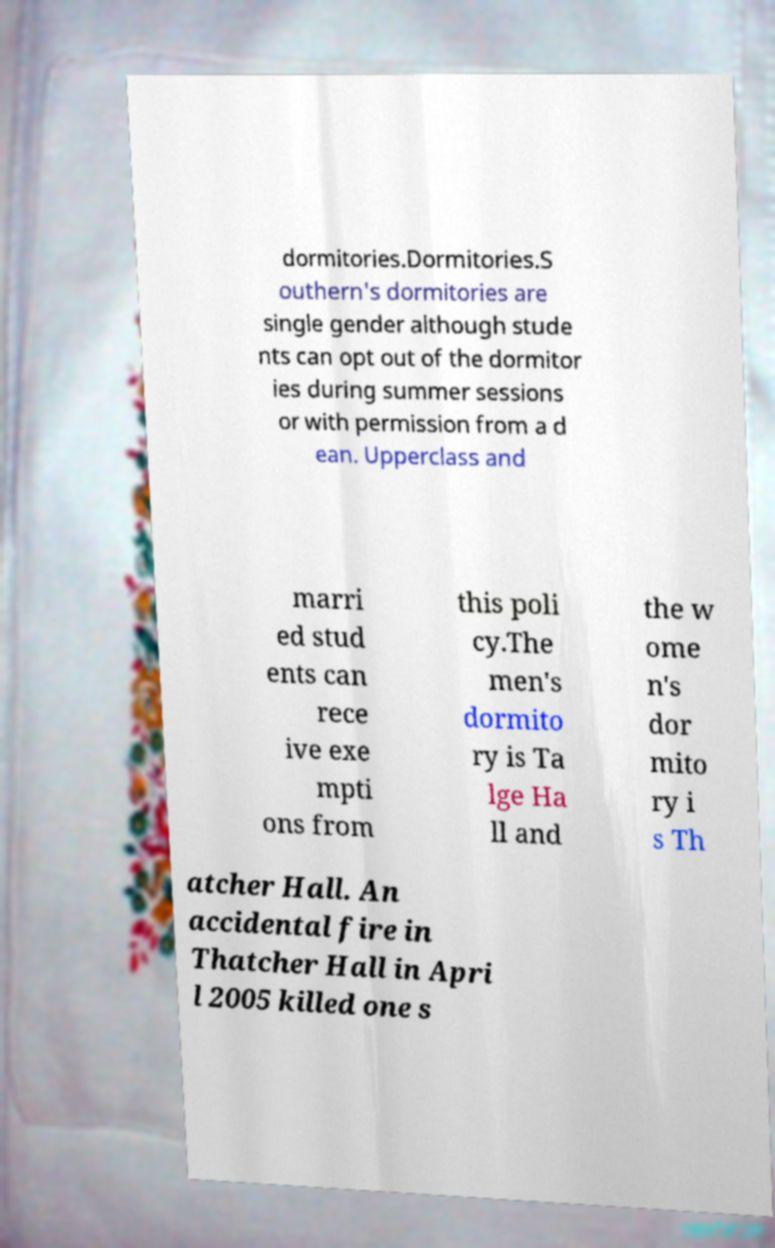Can you accurately transcribe the text from the provided image for me? dormitories.Dormitories.S outhern's dormitories are single gender although stude nts can opt out of the dormitor ies during summer sessions or with permission from a d ean. Upperclass and marri ed stud ents can rece ive exe mpti ons from this poli cy.The men's dormito ry is Ta lge Ha ll and the w ome n's dor mito ry i s Th atcher Hall. An accidental fire in Thatcher Hall in Apri l 2005 killed one s 